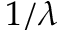Convert formula to latex. <formula><loc_0><loc_0><loc_500><loc_500>1 / \lambda</formula> 